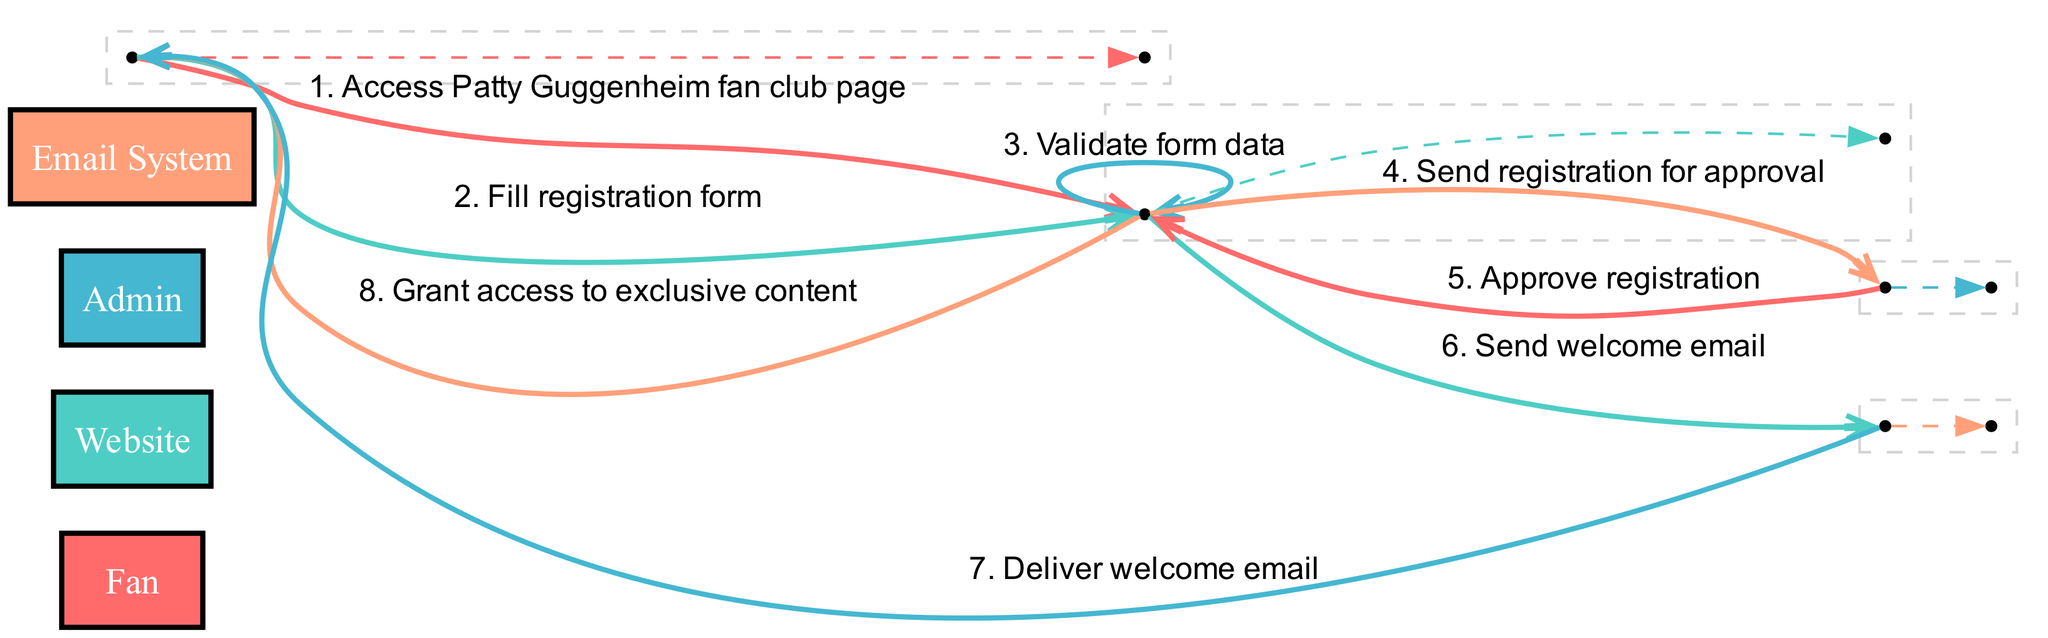What is the first action in the sequence? The first action is when the Fan accesses the Patty Guggenheim fan club page, as indicated by the first event in the sequence of actions.
Answer: Access Patty Guggenheim fan club page How many actors are involved in this sequence? There are four actors listed in the diagram: Fan, Website, Admin, and Email System. Counting these gives a total of four actors.
Answer: 4 Which actor is responsible for sending the registration for approval? The Website is responsible for sending the registration for approval after validating the form data, as shown in the fourth action of the sequence.
Answer: Website What action occurs just before the welcome email is delivered to the Fan? The action that occurs just before the welcome email is delivered is when the Website sends the welcome email to the Email System, which is indicated as the sixth action.
Answer: Send welcome email What is the last action completed in the sequence? The last action completed in the sequence is when the Website grants access to exclusive content to the Fan, which is shown as the eighth action in the sequence.
Answer: Grant access to exclusive content What is the relationship between the Website and the Admin regarding registration? The relationship is that the Website sends the registration for approval to the Admin, which indicates a flow of information from the Website to the Admin for the purpose of approval.
Answer: Send registration for approval Which two actors are directly connected by the action of approving registration? The Admin and the Website are directly connected by the action where the Admin approves the registration, marked as the fifth action in the sequence.
Answer: Admin and Website How many distinct actions are there in the sequence? There are eight distinct actions in the sequence, each representing a step in the fan club membership registration and approval process. Counting these provides the total.
Answer: 8 What is the function of the Email System in this sequence? The Email System's function is to deliver the welcome email to the Fan after the Website sends the welcome email to it, as shown in the sequence.
Answer: Deliver welcome email 